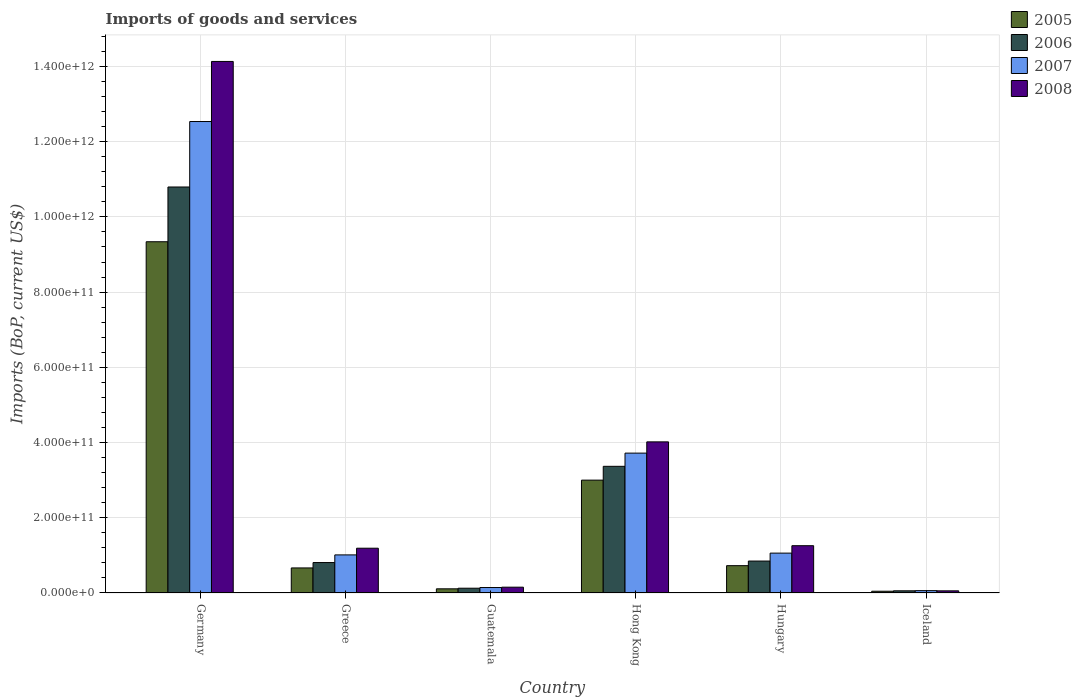How many different coloured bars are there?
Offer a terse response. 4. How many groups of bars are there?
Provide a succinct answer. 6. Are the number of bars per tick equal to the number of legend labels?
Offer a terse response. Yes. Are the number of bars on each tick of the X-axis equal?
Offer a very short reply. Yes. In how many cases, is the number of bars for a given country not equal to the number of legend labels?
Provide a succinct answer. 0. What is the amount spent on imports in 2008 in Germany?
Ensure brevity in your answer.  1.41e+12. Across all countries, what is the maximum amount spent on imports in 2007?
Offer a very short reply. 1.25e+12. Across all countries, what is the minimum amount spent on imports in 2008?
Your response must be concise. 5.71e+09. In which country was the amount spent on imports in 2006 maximum?
Your response must be concise. Germany. In which country was the amount spent on imports in 2007 minimum?
Offer a very short reply. Iceland. What is the total amount spent on imports in 2005 in the graph?
Make the answer very short. 1.39e+12. What is the difference between the amount spent on imports in 2006 in Guatemala and that in Hong Kong?
Offer a very short reply. -3.24e+11. What is the difference between the amount spent on imports in 2006 in Guatemala and the amount spent on imports in 2007 in Germany?
Ensure brevity in your answer.  -1.24e+12. What is the average amount spent on imports in 2007 per country?
Provide a succinct answer. 3.09e+11. What is the difference between the amount spent on imports of/in 2008 and amount spent on imports of/in 2006 in Iceland?
Keep it short and to the point. -1.07e+08. In how many countries, is the amount spent on imports in 2007 greater than 600000000000 US$?
Your answer should be compact. 1. What is the ratio of the amount spent on imports in 2008 in Germany to that in Iceland?
Offer a terse response. 247.52. Is the difference between the amount spent on imports in 2008 in Greece and Hungary greater than the difference between the amount spent on imports in 2006 in Greece and Hungary?
Provide a succinct answer. No. What is the difference between the highest and the second highest amount spent on imports in 2005?
Give a very brief answer. 6.34e+11. What is the difference between the highest and the lowest amount spent on imports in 2007?
Offer a terse response. 1.25e+12. In how many countries, is the amount spent on imports in 2007 greater than the average amount spent on imports in 2007 taken over all countries?
Provide a short and direct response. 2. Is the sum of the amount spent on imports in 2006 in Greece and Iceland greater than the maximum amount spent on imports in 2007 across all countries?
Your answer should be very brief. No. Is it the case that in every country, the sum of the amount spent on imports in 2008 and amount spent on imports in 2007 is greater than the sum of amount spent on imports in 2006 and amount spent on imports in 2005?
Offer a terse response. No. What does the 4th bar from the left in Iceland represents?
Your response must be concise. 2008. Is it the case that in every country, the sum of the amount spent on imports in 2007 and amount spent on imports in 2008 is greater than the amount spent on imports in 2005?
Your answer should be compact. Yes. How many bars are there?
Offer a terse response. 24. Are all the bars in the graph horizontal?
Your response must be concise. No. How many countries are there in the graph?
Make the answer very short. 6. What is the difference between two consecutive major ticks on the Y-axis?
Your answer should be very brief. 2.00e+11. Does the graph contain any zero values?
Provide a succinct answer. No. Does the graph contain grids?
Your response must be concise. Yes. How many legend labels are there?
Ensure brevity in your answer.  4. How are the legend labels stacked?
Provide a succinct answer. Vertical. What is the title of the graph?
Give a very brief answer. Imports of goods and services. What is the label or title of the X-axis?
Your answer should be very brief. Country. What is the label or title of the Y-axis?
Your response must be concise. Imports (BoP, current US$). What is the Imports (BoP, current US$) of 2005 in Germany?
Your answer should be compact. 9.34e+11. What is the Imports (BoP, current US$) in 2006 in Germany?
Keep it short and to the point. 1.08e+12. What is the Imports (BoP, current US$) in 2007 in Germany?
Offer a terse response. 1.25e+12. What is the Imports (BoP, current US$) of 2008 in Germany?
Offer a terse response. 1.41e+12. What is the Imports (BoP, current US$) of 2005 in Greece?
Ensure brevity in your answer.  6.66e+1. What is the Imports (BoP, current US$) of 2006 in Greece?
Ensure brevity in your answer.  8.09e+1. What is the Imports (BoP, current US$) in 2007 in Greece?
Your answer should be very brief. 1.01e+11. What is the Imports (BoP, current US$) in 2008 in Greece?
Make the answer very short. 1.19e+11. What is the Imports (BoP, current US$) of 2005 in Guatemala?
Your response must be concise. 1.11e+1. What is the Imports (BoP, current US$) of 2006 in Guatemala?
Your answer should be very brief. 1.27e+1. What is the Imports (BoP, current US$) in 2007 in Guatemala?
Make the answer very short. 1.45e+1. What is the Imports (BoP, current US$) in 2008 in Guatemala?
Offer a terse response. 1.55e+1. What is the Imports (BoP, current US$) in 2005 in Hong Kong?
Your answer should be compact. 3.00e+11. What is the Imports (BoP, current US$) in 2006 in Hong Kong?
Your answer should be very brief. 3.37e+11. What is the Imports (BoP, current US$) in 2007 in Hong Kong?
Your response must be concise. 3.72e+11. What is the Imports (BoP, current US$) in 2008 in Hong Kong?
Ensure brevity in your answer.  4.02e+11. What is the Imports (BoP, current US$) in 2005 in Hungary?
Provide a succinct answer. 7.26e+1. What is the Imports (BoP, current US$) of 2006 in Hungary?
Keep it short and to the point. 8.49e+1. What is the Imports (BoP, current US$) of 2007 in Hungary?
Ensure brevity in your answer.  1.06e+11. What is the Imports (BoP, current US$) in 2008 in Hungary?
Provide a short and direct response. 1.26e+11. What is the Imports (BoP, current US$) in 2005 in Iceland?
Offer a terse response. 4.68e+09. What is the Imports (BoP, current US$) of 2006 in Iceland?
Provide a succinct answer. 5.82e+09. What is the Imports (BoP, current US$) in 2007 in Iceland?
Offer a very short reply. 6.27e+09. What is the Imports (BoP, current US$) in 2008 in Iceland?
Ensure brevity in your answer.  5.71e+09. Across all countries, what is the maximum Imports (BoP, current US$) in 2005?
Your answer should be very brief. 9.34e+11. Across all countries, what is the maximum Imports (BoP, current US$) of 2006?
Make the answer very short. 1.08e+12. Across all countries, what is the maximum Imports (BoP, current US$) in 2007?
Your answer should be very brief. 1.25e+12. Across all countries, what is the maximum Imports (BoP, current US$) of 2008?
Your answer should be compact. 1.41e+12. Across all countries, what is the minimum Imports (BoP, current US$) in 2005?
Keep it short and to the point. 4.68e+09. Across all countries, what is the minimum Imports (BoP, current US$) in 2006?
Offer a terse response. 5.82e+09. Across all countries, what is the minimum Imports (BoP, current US$) of 2007?
Keep it short and to the point. 6.27e+09. Across all countries, what is the minimum Imports (BoP, current US$) in 2008?
Offer a very short reply. 5.71e+09. What is the total Imports (BoP, current US$) of 2005 in the graph?
Your response must be concise. 1.39e+12. What is the total Imports (BoP, current US$) of 2006 in the graph?
Offer a very short reply. 1.60e+12. What is the total Imports (BoP, current US$) in 2007 in the graph?
Keep it short and to the point. 1.85e+12. What is the total Imports (BoP, current US$) of 2008 in the graph?
Your answer should be compact. 2.08e+12. What is the difference between the Imports (BoP, current US$) in 2005 in Germany and that in Greece?
Offer a very short reply. 8.67e+11. What is the difference between the Imports (BoP, current US$) in 2006 in Germany and that in Greece?
Give a very brief answer. 9.98e+11. What is the difference between the Imports (BoP, current US$) in 2007 in Germany and that in Greece?
Give a very brief answer. 1.15e+12. What is the difference between the Imports (BoP, current US$) of 2008 in Germany and that in Greece?
Make the answer very short. 1.29e+12. What is the difference between the Imports (BoP, current US$) in 2005 in Germany and that in Guatemala?
Ensure brevity in your answer.  9.23e+11. What is the difference between the Imports (BoP, current US$) of 2006 in Germany and that in Guatemala?
Provide a succinct answer. 1.07e+12. What is the difference between the Imports (BoP, current US$) of 2007 in Germany and that in Guatemala?
Your response must be concise. 1.24e+12. What is the difference between the Imports (BoP, current US$) in 2008 in Germany and that in Guatemala?
Offer a terse response. 1.40e+12. What is the difference between the Imports (BoP, current US$) of 2005 in Germany and that in Hong Kong?
Provide a succinct answer. 6.34e+11. What is the difference between the Imports (BoP, current US$) in 2006 in Germany and that in Hong Kong?
Give a very brief answer. 7.43e+11. What is the difference between the Imports (BoP, current US$) in 2007 in Germany and that in Hong Kong?
Keep it short and to the point. 8.82e+11. What is the difference between the Imports (BoP, current US$) in 2008 in Germany and that in Hong Kong?
Your answer should be compact. 1.01e+12. What is the difference between the Imports (BoP, current US$) of 2005 in Germany and that in Hungary?
Your response must be concise. 8.61e+11. What is the difference between the Imports (BoP, current US$) of 2006 in Germany and that in Hungary?
Offer a very short reply. 9.95e+11. What is the difference between the Imports (BoP, current US$) in 2007 in Germany and that in Hungary?
Provide a short and direct response. 1.15e+12. What is the difference between the Imports (BoP, current US$) in 2008 in Germany and that in Hungary?
Provide a succinct answer. 1.29e+12. What is the difference between the Imports (BoP, current US$) of 2005 in Germany and that in Iceland?
Your response must be concise. 9.29e+11. What is the difference between the Imports (BoP, current US$) of 2006 in Germany and that in Iceland?
Make the answer very short. 1.07e+12. What is the difference between the Imports (BoP, current US$) in 2007 in Germany and that in Iceland?
Offer a terse response. 1.25e+12. What is the difference between the Imports (BoP, current US$) in 2008 in Germany and that in Iceland?
Make the answer very short. 1.41e+12. What is the difference between the Imports (BoP, current US$) in 2005 in Greece and that in Guatemala?
Ensure brevity in your answer.  5.55e+1. What is the difference between the Imports (BoP, current US$) of 2006 in Greece and that in Guatemala?
Make the answer very short. 6.82e+1. What is the difference between the Imports (BoP, current US$) in 2007 in Greece and that in Guatemala?
Ensure brevity in your answer.  8.68e+1. What is the difference between the Imports (BoP, current US$) in 2008 in Greece and that in Guatemala?
Keep it short and to the point. 1.04e+11. What is the difference between the Imports (BoP, current US$) of 2005 in Greece and that in Hong Kong?
Keep it short and to the point. -2.33e+11. What is the difference between the Imports (BoP, current US$) of 2006 in Greece and that in Hong Kong?
Offer a very short reply. -2.56e+11. What is the difference between the Imports (BoP, current US$) of 2007 in Greece and that in Hong Kong?
Ensure brevity in your answer.  -2.71e+11. What is the difference between the Imports (BoP, current US$) in 2008 in Greece and that in Hong Kong?
Your answer should be very brief. -2.83e+11. What is the difference between the Imports (BoP, current US$) of 2005 in Greece and that in Hungary?
Ensure brevity in your answer.  -6.02e+09. What is the difference between the Imports (BoP, current US$) in 2006 in Greece and that in Hungary?
Your answer should be compact. -3.99e+09. What is the difference between the Imports (BoP, current US$) of 2007 in Greece and that in Hungary?
Ensure brevity in your answer.  -4.71e+09. What is the difference between the Imports (BoP, current US$) of 2008 in Greece and that in Hungary?
Ensure brevity in your answer.  -6.66e+09. What is the difference between the Imports (BoP, current US$) in 2005 in Greece and that in Iceland?
Give a very brief answer. 6.19e+1. What is the difference between the Imports (BoP, current US$) of 2006 in Greece and that in Iceland?
Offer a very short reply. 7.51e+1. What is the difference between the Imports (BoP, current US$) in 2007 in Greece and that in Iceland?
Give a very brief answer. 9.50e+1. What is the difference between the Imports (BoP, current US$) of 2008 in Greece and that in Iceland?
Provide a short and direct response. 1.13e+11. What is the difference between the Imports (BoP, current US$) of 2005 in Guatemala and that in Hong Kong?
Your answer should be very brief. -2.89e+11. What is the difference between the Imports (BoP, current US$) of 2006 in Guatemala and that in Hong Kong?
Your answer should be very brief. -3.24e+11. What is the difference between the Imports (BoP, current US$) in 2007 in Guatemala and that in Hong Kong?
Your response must be concise. -3.57e+11. What is the difference between the Imports (BoP, current US$) in 2008 in Guatemala and that in Hong Kong?
Make the answer very short. -3.86e+11. What is the difference between the Imports (BoP, current US$) of 2005 in Guatemala and that in Hungary?
Offer a terse response. -6.15e+1. What is the difference between the Imports (BoP, current US$) in 2006 in Guatemala and that in Hungary?
Offer a terse response. -7.22e+1. What is the difference between the Imports (BoP, current US$) in 2007 in Guatemala and that in Hungary?
Provide a succinct answer. -9.15e+1. What is the difference between the Imports (BoP, current US$) in 2008 in Guatemala and that in Hungary?
Your response must be concise. -1.10e+11. What is the difference between the Imports (BoP, current US$) in 2005 in Guatemala and that in Iceland?
Your answer should be very brief. 6.42e+09. What is the difference between the Imports (BoP, current US$) in 2006 in Guatemala and that in Iceland?
Your answer should be compact. 6.90e+09. What is the difference between the Imports (BoP, current US$) in 2007 in Guatemala and that in Iceland?
Ensure brevity in your answer.  8.24e+09. What is the difference between the Imports (BoP, current US$) in 2008 in Guatemala and that in Iceland?
Provide a succinct answer. 9.75e+09. What is the difference between the Imports (BoP, current US$) of 2005 in Hong Kong and that in Hungary?
Offer a terse response. 2.27e+11. What is the difference between the Imports (BoP, current US$) of 2006 in Hong Kong and that in Hungary?
Ensure brevity in your answer.  2.52e+11. What is the difference between the Imports (BoP, current US$) of 2007 in Hong Kong and that in Hungary?
Make the answer very short. 2.66e+11. What is the difference between the Imports (BoP, current US$) of 2008 in Hong Kong and that in Hungary?
Ensure brevity in your answer.  2.76e+11. What is the difference between the Imports (BoP, current US$) of 2005 in Hong Kong and that in Iceland?
Your answer should be very brief. 2.95e+11. What is the difference between the Imports (BoP, current US$) of 2006 in Hong Kong and that in Iceland?
Offer a terse response. 3.31e+11. What is the difference between the Imports (BoP, current US$) in 2007 in Hong Kong and that in Iceland?
Provide a succinct answer. 3.66e+11. What is the difference between the Imports (BoP, current US$) of 2008 in Hong Kong and that in Iceland?
Your answer should be very brief. 3.96e+11. What is the difference between the Imports (BoP, current US$) of 2005 in Hungary and that in Iceland?
Offer a very short reply. 6.80e+1. What is the difference between the Imports (BoP, current US$) of 2006 in Hungary and that in Iceland?
Offer a terse response. 7.91e+1. What is the difference between the Imports (BoP, current US$) of 2007 in Hungary and that in Iceland?
Provide a succinct answer. 9.97e+1. What is the difference between the Imports (BoP, current US$) in 2008 in Hungary and that in Iceland?
Provide a short and direct response. 1.20e+11. What is the difference between the Imports (BoP, current US$) in 2005 in Germany and the Imports (BoP, current US$) in 2006 in Greece?
Give a very brief answer. 8.53e+11. What is the difference between the Imports (BoP, current US$) of 2005 in Germany and the Imports (BoP, current US$) of 2007 in Greece?
Your answer should be very brief. 8.33e+11. What is the difference between the Imports (BoP, current US$) in 2005 in Germany and the Imports (BoP, current US$) in 2008 in Greece?
Provide a short and direct response. 8.15e+11. What is the difference between the Imports (BoP, current US$) of 2006 in Germany and the Imports (BoP, current US$) of 2007 in Greece?
Your response must be concise. 9.78e+11. What is the difference between the Imports (BoP, current US$) in 2006 in Germany and the Imports (BoP, current US$) in 2008 in Greece?
Provide a succinct answer. 9.60e+11. What is the difference between the Imports (BoP, current US$) in 2007 in Germany and the Imports (BoP, current US$) in 2008 in Greece?
Ensure brevity in your answer.  1.13e+12. What is the difference between the Imports (BoP, current US$) of 2005 in Germany and the Imports (BoP, current US$) of 2006 in Guatemala?
Keep it short and to the point. 9.21e+11. What is the difference between the Imports (BoP, current US$) of 2005 in Germany and the Imports (BoP, current US$) of 2007 in Guatemala?
Provide a succinct answer. 9.19e+11. What is the difference between the Imports (BoP, current US$) of 2005 in Germany and the Imports (BoP, current US$) of 2008 in Guatemala?
Offer a terse response. 9.18e+11. What is the difference between the Imports (BoP, current US$) in 2006 in Germany and the Imports (BoP, current US$) in 2007 in Guatemala?
Keep it short and to the point. 1.06e+12. What is the difference between the Imports (BoP, current US$) of 2006 in Germany and the Imports (BoP, current US$) of 2008 in Guatemala?
Give a very brief answer. 1.06e+12. What is the difference between the Imports (BoP, current US$) of 2007 in Germany and the Imports (BoP, current US$) of 2008 in Guatemala?
Your answer should be compact. 1.24e+12. What is the difference between the Imports (BoP, current US$) in 2005 in Germany and the Imports (BoP, current US$) in 2006 in Hong Kong?
Give a very brief answer. 5.97e+11. What is the difference between the Imports (BoP, current US$) of 2005 in Germany and the Imports (BoP, current US$) of 2007 in Hong Kong?
Give a very brief answer. 5.62e+11. What is the difference between the Imports (BoP, current US$) of 2005 in Germany and the Imports (BoP, current US$) of 2008 in Hong Kong?
Offer a very short reply. 5.32e+11. What is the difference between the Imports (BoP, current US$) of 2006 in Germany and the Imports (BoP, current US$) of 2007 in Hong Kong?
Your response must be concise. 7.08e+11. What is the difference between the Imports (BoP, current US$) in 2006 in Germany and the Imports (BoP, current US$) in 2008 in Hong Kong?
Give a very brief answer. 6.78e+11. What is the difference between the Imports (BoP, current US$) of 2007 in Germany and the Imports (BoP, current US$) of 2008 in Hong Kong?
Your answer should be compact. 8.52e+11. What is the difference between the Imports (BoP, current US$) in 2005 in Germany and the Imports (BoP, current US$) in 2006 in Hungary?
Provide a succinct answer. 8.49e+11. What is the difference between the Imports (BoP, current US$) of 2005 in Germany and the Imports (BoP, current US$) of 2007 in Hungary?
Provide a short and direct response. 8.28e+11. What is the difference between the Imports (BoP, current US$) in 2005 in Germany and the Imports (BoP, current US$) in 2008 in Hungary?
Make the answer very short. 8.08e+11. What is the difference between the Imports (BoP, current US$) in 2006 in Germany and the Imports (BoP, current US$) in 2007 in Hungary?
Provide a short and direct response. 9.73e+11. What is the difference between the Imports (BoP, current US$) in 2006 in Germany and the Imports (BoP, current US$) in 2008 in Hungary?
Your answer should be compact. 9.54e+11. What is the difference between the Imports (BoP, current US$) of 2007 in Germany and the Imports (BoP, current US$) of 2008 in Hungary?
Make the answer very short. 1.13e+12. What is the difference between the Imports (BoP, current US$) of 2005 in Germany and the Imports (BoP, current US$) of 2006 in Iceland?
Your answer should be very brief. 9.28e+11. What is the difference between the Imports (BoP, current US$) in 2005 in Germany and the Imports (BoP, current US$) in 2007 in Iceland?
Your answer should be very brief. 9.28e+11. What is the difference between the Imports (BoP, current US$) of 2005 in Germany and the Imports (BoP, current US$) of 2008 in Iceland?
Your answer should be compact. 9.28e+11. What is the difference between the Imports (BoP, current US$) of 2006 in Germany and the Imports (BoP, current US$) of 2007 in Iceland?
Your response must be concise. 1.07e+12. What is the difference between the Imports (BoP, current US$) of 2006 in Germany and the Imports (BoP, current US$) of 2008 in Iceland?
Keep it short and to the point. 1.07e+12. What is the difference between the Imports (BoP, current US$) in 2007 in Germany and the Imports (BoP, current US$) in 2008 in Iceland?
Your answer should be compact. 1.25e+12. What is the difference between the Imports (BoP, current US$) of 2005 in Greece and the Imports (BoP, current US$) of 2006 in Guatemala?
Keep it short and to the point. 5.39e+1. What is the difference between the Imports (BoP, current US$) in 2005 in Greece and the Imports (BoP, current US$) in 2007 in Guatemala?
Your answer should be very brief. 5.21e+1. What is the difference between the Imports (BoP, current US$) in 2005 in Greece and the Imports (BoP, current US$) in 2008 in Guatemala?
Offer a very short reply. 5.12e+1. What is the difference between the Imports (BoP, current US$) of 2006 in Greece and the Imports (BoP, current US$) of 2007 in Guatemala?
Provide a succinct answer. 6.64e+1. What is the difference between the Imports (BoP, current US$) in 2006 in Greece and the Imports (BoP, current US$) in 2008 in Guatemala?
Give a very brief answer. 6.55e+1. What is the difference between the Imports (BoP, current US$) of 2007 in Greece and the Imports (BoP, current US$) of 2008 in Guatemala?
Provide a short and direct response. 8.58e+1. What is the difference between the Imports (BoP, current US$) in 2005 in Greece and the Imports (BoP, current US$) in 2006 in Hong Kong?
Your response must be concise. -2.70e+11. What is the difference between the Imports (BoP, current US$) of 2005 in Greece and the Imports (BoP, current US$) of 2007 in Hong Kong?
Your response must be concise. -3.05e+11. What is the difference between the Imports (BoP, current US$) of 2005 in Greece and the Imports (BoP, current US$) of 2008 in Hong Kong?
Provide a short and direct response. -3.35e+11. What is the difference between the Imports (BoP, current US$) of 2006 in Greece and the Imports (BoP, current US$) of 2007 in Hong Kong?
Make the answer very short. -2.91e+11. What is the difference between the Imports (BoP, current US$) of 2006 in Greece and the Imports (BoP, current US$) of 2008 in Hong Kong?
Keep it short and to the point. -3.21e+11. What is the difference between the Imports (BoP, current US$) in 2007 in Greece and the Imports (BoP, current US$) in 2008 in Hong Kong?
Offer a very short reply. -3.01e+11. What is the difference between the Imports (BoP, current US$) in 2005 in Greece and the Imports (BoP, current US$) in 2006 in Hungary?
Your response must be concise. -1.83e+1. What is the difference between the Imports (BoP, current US$) in 2005 in Greece and the Imports (BoP, current US$) in 2007 in Hungary?
Provide a short and direct response. -3.94e+1. What is the difference between the Imports (BoP, current US$) of 2005 in Greece and the Imports (BoP, current US$) of 2008 in Hungary?
Offer a terse response. -5.91e+1. What is the difference between the Imports (BoP, current US$) in 2006 in Greece and the Imports (BoP, current US$) in 2007 in Hungary?
Keep it short and to the point. -2.51e+1. What is the difference between the Imports (BoP, current US$) in 2006 in Greece and the Imports (BoP, current US$) in 2008 in Hungary?
Provide a succinct answer. -4.48e+1. What is the difference between the Imports (BoP, current US$) of 2007 in Greece and the Imports (BoP, current US$) of 2008 in Hungary?
Ensure brevity in your answer.  -2.44e+1. What is the difference between the Imports (BoP, current US$) of 2005 in Greece and the Imports (BoP, current US$) of 2006 in Iceland?
Offer a terse response. 6.08e+1. What is the difference between the Imports (BoP, current US$) in 2005 in Greece and the Imports (BoP, current US$) in 2007 in Iceland?
Make the answer very short. 6.03e+1. What is the difference between the Imports (BoP, current US$) of 2005 in Greece and the Imports (BoP, current US$) of 2008 in Iceland?
Provide a succinct answer. 6.09e+1. What is the difference between the Imports (BoP, current US$) in 2006 in Greece and the Imports (BoP, current US$) in 2007 in Iceland?
Your answer should be compact. 7.47e+1. What is the difference between the Imports (BoP, current US$) in 2006 in Greece and the Imports (BoP, current US$) in 2008 in Iceland?
Make the answer very short. 7.52e+1. What is the difference between the Imports (BoP, current US$) of 2007 in Greece and the Imports (BoP, current US$) of 2008 in Iceland?
Give a very brief answer. 9.56e+1. What is the difference between the Imports (BoP, current US$) of 2005 in Guatemala and the Imports (BoP, current US$) of 2006 in Hong Kong?
Your answer should be very brief. -3.26e+11. What is the difference between the Imports (BoP, current US$) of 2005 in Guatemala and the Imports (BoP, current US$) of 2007 in Hong Kong?
Give a very brief answer. -3.61e+11. What is the difference between the Imports (BoP, current US$) in 2005 in Guatemala and the Imports (BoP, current US$) in 2008 in Hong Kong?
Provide a short and direct response. -3.91e+11. What is the difference between the Imports (BoP, current US$) of 2006 in Guatemala and the Imports (BoP, current US$) of 2007 in Hong Kong?
Give a very brief answer. -3.59e+11. What is the difference between the Imports (BoP, current US$) in 2006 in Guatemala and the Imports (BoP, current US$) in 2008 in Hong Kong?
Give a very brief answer. -3.89e+11. What is the difference between the Imports (BoP, current US$) of 2007 in Guatemala and the Imports (BoP, current US$) of 2008 in Hong Kong?
Keep it short and to the point. -3.87e+11. What is the difference between the Imports (BoP, current US$) of 2005 in Guatemala and the Imports (BoP, current US$) of 2006 in Hungary?
Give a very brief answer. -7.38e+1. What is the difference between the Imports (BoP, current US$) in 2005 in Guatemala and the Imports (BoP, current US$) in 2007 in Hungary?
Give a very brief answer. -9.49e+1. What is the difference between the Imports (BoP, current US$) in 2005 in Guatemala and the Imports (BoP, current US$) in 2008 in Hungary?
Your answer should be very brief. -1.15e+11. What is the difference between the Imports (BoP, current US$) of 2006 in Guatemala and the Imports (BoP, current US$) of 2007 in Hungary?
Provide a succinct answer. -9.33e+1. What is the difference between the Imports (BoP, current US$) in 2006 in Guatemala and the Imports (BoP, current US$) in 2008 in Hungary?
Offer a very short reply. -1.13e+11. What is the difference between the Imports (BoP, current US$) of 2007 in Guatemala and the Imports (BoP, current US$) of 2008 in Hungary?
Keep it short and to the point. -1.11e+11. What is the difference between the Imports (BoP, current US$) of 2005 in Guatemala and the Imports (BoP, current US$) of 2006 in Iceland?
Ensure brevity in your answer.  5.28e+09. What is the difference between the Imports (BoP, current US$) in 2005 in Guatemala and the Imports (BoP, current US$) in 2007 in Iceland?
Make the answer very short. 4.83e+09. What is the difference between the Imports (BoP, current US$) in 2005 in Guatemala and the Imports (BoP, current US$) in 2008 in Iceland?
Keep it short and to the point. 5.39e+09. What is the difference between the Imports (BoP, current US$) in 2006 in Guatemala and the Imports (BoP, current US$) in 2007 in Iceland?
Make the answer very short. 6.44e+09. What is the difference between the Imports (BoP, current US$) of 2006 in Guatemala and the Imports (BoP, current US$) of 2008 in Iceland?
Provide a short and direct response. 7.00e+09. What is the difference between the Imports (BoP, current US$) in 2007 in Guatemala and the Imports (BoP, current US$) in 2008 in Iceland?
Your answer should be compact. 8.80e+09. What is the difference between the Imports (BoP, current US$) in 2005 in Hong Kong and the Imports (BoP, current US$) in 2006 in Hungary?
Offer a very short reply. 2.15e+11. What is the difference between the Imports (BoP, current US$) of 2005 in Hong Kong and the Imports (BoP, current US$) of 2007 in Hungary?
Give a very brief answer. 1.94e+11. What is the difference between the Imports (BoP, current US$) in 2005 in Hong Kong and the Imports (BoP, current US$) in 2008 in Hungary?
Your answer should be compact. 1.74e+11. What is the difference between the Imports (BoP, current US$) of 2006 in Hong Kong and the Imports (BoP, current US$) of 2007 in Hungary?
Make the answer very short. 2.31e+11. What is the difference between the Imports (BoP, current US$) in 2006 in Hong Kong and the Imports (BoP, current US$) in 2008 in Hungary?
Your answer should be very brief. 2.11e+11. What is the difference between the Imports (BoP, current US$) of 2007 in Hong Kong and the Imports (BoP, current US$) of 2008 in Hungary?
Your response must be concise. 2.46e+11. What is the difference between the Imports (BoP, current US$) of 2005 in Hong Kong and the Imports (BoP, current US$) of 2006 in Iceland?
Provide a succinct answer. 2.94e+11. What is the difference between the Imports (BoP, current US$) in 2005 in Hong Kong and the Imports (BoP, current US$) in 2007 in Iceland?
Your response must be concise. 2.94e+11. What is the difference between the Imports (BoP, current US$) of 2005 in Hong Kong and the Imports (BoP, current US$) of 2008 in Iceland?
Make the answer very short. 2.94e+11. What is the difference between the Imports (BoP, current US$) of 2006 in Hong Kong and the Imports (BoP, current US$) of 2007 in Iceland?
Offer a very short reply. 3.30e+11. What is the difference between the Imports (BoP, current US$) in 2006 in Hong Kong and the Imports (BoP, current US$) in 2008 in Iceland?
Your answer should be compact. 3.31e+11. What is the difference between the Imports (BoP, current US$) of 2007 in Hong Kong and the Imports (BoP, current US$) of 2008 in Iceland?
Provide a short and direct response. 3.66e+11. What is the difference between the Imports (BoP, current US$) in 2005 in Hungary and the Imports (BoP, current US$) in 2006 in Iceland?
Make the answer very short. 6.68e+1. What is the difference between the Imports (BoP, current US$) in 2005 in Hungary and the Imports (BoP, current US$) in 2007 in Iceland?
Provide a short and direct response. 6.64e+1. What is the difference between the Imports (BoP, current US$) in 2005 in Hungary and the Imports (BoP, current US$) in 2008 in Iceland?
Your response must be concise. 6.69e+1. What is the difference between the Imports (BoP, current US$) of 2006 in Hungary and the Imports (BoP, current US$) of 2007 in Iceland?
Your response must be concise. 7.86e+1. What is the difference between the Imports (BoP, current US$) in 2006 in Hungary and the Imports (BoP, current US$) in 2008 in Iceland?
Provide a succinct answer. 7.92e+1. What is the difference between the Imports (BoP, current US$) of 2007 in Hungary and the Imports (BoP, current US$) of 2008 in Iceland?
Your answer should be compact. 1.00e+11. What is the average Imports (BoP, current US$) in 2005 per country?
Offer a terse response. 2.31e+11. What is the average Imports (BoP, current US$) of 2006 per country?
Make the answer very short. 2.67e+11. What is the average Imports (BoP, current US$) of 2007 per country?
Keep it short and to the point. 3.09e+11. What is the average Imports (BoP, current US$) in 2008 per country?
Make the answer very short. 3.47e+11. What is the difference between the Imports (BoP, current US$) in 2005 and Imports (BoP, current US$) in 2006 in Germany?
Your answer should be compact. -1.46e+11. What is the difference between the Imports (BoP, current US$) of 2005 and Imports (BoP, current US$) of 2007 in Germany?
Keep it short and to the point. -3.20e+11. What is the difference between the Imports (BoP, current US$) of 2005 and Imports (BoP, current US$) of 2008 in Germany?
Offer a very short reply. -4.79e+11. What is the difference between the Imports (BoP, current US$) of 2006 and Imports (BoP, current US$) of 2007 in Germany?
Provide a succinct answer. -1.74e+11. What is the difference between the Imports (BoP, current US$) of 2006 and Imports (BoP, current US$) of 2008 in Germany?
Provide a succinct answer. -3.34e+11. What is the difference between the Imports (BoP, current US$) in 2007 and Imports (BoP, current US$) in 2008 in Germany?
Ensure brevity in your answer.  -1.60e+11. What is the difference between the Imports (BoP, current US$) of 2005 and Imports (BoP, current US$) of 2006 in Greece?
Offer a terse response. -1.43e+1. What is the difference between the Imports (BoP, current US$) of 2005 and Imports (BoP, current US$) of 2007 in Greece?
Provide a succinct answer. -3.47e+1. What is the difference between the Imports (BoP, current US$) in 2005 and Imports (BoP, current US$) in 2008 in Greece?
Your answer should be compact. -5.25e+1. What is the difference between the Imports (BoP, current US$) in 2006 and Imports (BoP, current US$) in 2007 in Greece?
Make the answer very short. -2.04e+1. What is the difference between the Imports (BoP, current US$) of 2006 and Imports (BoP, current US$) of 2008 in Greece?
Your response must be concise. -3.81e+1. What is the difference between the Imports (BoP, current US$) in 2007 and Imports (BoP, current US$) in 2008 in Greece?
Your response must be concise. -1.78e+1. What is the difference between the Imports (BoP, current US$) of 2005 and Imports (BoP, current US$) of 2006 in Guatemala?
Offer a very short reply. -1.61e+09. What is the difference between the Imports (BoP, current US$) of 2005 and Imports (BoP, current US$) of 2007 in Guatemala?
Offer a terse response. -3.41e+09. What is the difference between the Imports (BoP, current US$) of 2005 and Imports (BoP, current US$) of 2008 in Guatemala?
Keep it short and to the point. -4.36e+09. What is the difference between the Imports (BoP, current US$) in 2006 and Imports (BoP, current US$) in 2007 in Guatemala?
Your answer should be compact. -1.80e+09. What is the difference between the Imports (BoP, current US$) of 2006 and Imports (BoP, current US$) of 2008 in Guatemala?
Your answer should be very brief. -2.75e+09. What is the difference between the Imports (BoP, current US$) of 2007 and Imports (BoP, current US$) of 2008 in Guatemala?
Your answer should be very brief. -9.53e+08. What is the difference between the Imports (BoP, current US$) in 2005 and Imports (BoP, current US$) in 2006 in Hong Kong?
Offer a terse response. -3.67e+1. What is the difference between the Imports (BoP, current US$) in 2005 and Imports (BoP, current US$) in 2007 in Hong Kong?
Provide a short and direct response. -7.18e+1. What is the difference between the Imports (BoP, current US$) in 2005 and Imports (BoP, current US$) in 2008 in Hong Kong?
Provide a short and direct response. -1.02e+11. What is the difference between the Imports (BoP, current US$) in 2006 and Imports (BoP, current US$) in 2007 in Hong Kong?
Provide a short and direct response. -3.51e+1. What is the difference between the Imports (BoP, current US$) in 2006 and Imports (BoP, current US$) in 2008 in Hong Kong?
Offer a very short reply. -6.50e+1. What is the difference between the Imports (BoP, current US$) in 2007 and Imports (BoP, current US$) in 2008 in Hong Kong?
Your answer should be compact. -2.99e+1. What is the difference between the Imports (BoP, current US$) in 2005 and Imports (BoP, current US$) in 2006 in Hungary?
Give a very brief answer. -1.23e+1. What is the difference between the Imports (BoP, current US$) of 2005 and Imports (BoP, current US$) of 2007 in Hungary?
Give a very brief answer. -3.33e+1. What is the difference between the Imports (BoP, current US$) in 2005 and Imports (BoP, current US$) in 2008 in Hungary?
Offer a terse response. -5.31e+1. What is the difference between the Imports (BoP, current US$) in 2006 and Imports (BoP, current US$) in 2007 in Hungary?
Give a very brief answer. -2.11e+1. What is the difference between the Imports (BoP, current US$) in 2006 and Imports (BoP, current US$) in 2008 in Hungary?
Provide a succinct answer. -4.08e+1. What is the difference between the Imports (BoP, current US$) in 2007 and Imports (BoP, current US$) in 2008 in Hungary?
Keep it short and to the point. -1.97e+1. What is the difference between the Imports (BoP, current US$) in 2005 and Imports (BoP, current US$) in 2006 in Iceland?
Ensure brevity in your answer.  -1.13e+09. What is the difference between the Imports (BoP, current US$) of 2005 and Imports (BoP, current US$) of 2007 in Iceland?
Ensure brevity in your answer.  -1.59e+09. What is the difference between the Imports (BoP, current US$) of 2005 and Imports (BoP, current US$) of 2008 in Iceland?
Provide a short and direct response. -1.03e+09. What is the difference between the Imports (BoP, current US$) in 2006 and Imports (BoP, current US$) in 2007 in Iceland?
Provide a succinct answer. -4.53e+08. What is the difference between the Imports (BoP, current US$) of 2006 and Imports (BoP, current US$) of 2008 in Iceland?
Provide a succinct answer. 1.07e+08. What is the difference between the Imports (BoP, current US$) of 2007 and Imports (BoP, current US$) of 2008 in Iceland?
Provide a succinct answer. 5.60e+08. What is the ratio of the Imports (BoP, current US$) in 2005 in Germany to that in Greece?
Give a very brief answer. 14.02. What is the ratio of the Imports (BoP, current US$) of 2006 in Germany to that in Greece?
Offer a very short reply. 13.34. What is the ratio of the Imports (BoP, current US$) of 2007 in Germany to that in Greece?
Give a very brief answer. 12.38. What is the ratio of the Imports (BoP, current US$) of 2008 in Germany to that in Greece?
Make the answer very short. 11.87. What is the ratio of the Imports (BoP, current US$) of 2005 in Germany to that in Guatemala?
Ensure brevity in your answer.  84.13. What is the ratio of the Imports (BoP, current US$) in 2006 in Germany to that in Guatemala?
Keep it short and to the point. 84.91. What is the ratio of the Imports (BoP, current US$) in 2007 in Germany to that in Guatemala?
Offer a very short reply. 86.38. What is the ratio of the Imports (BoP, current US$) in 2008 in Germany to that in Guatemala?
Your answer should be compact. 91.38. What is the ratio of the Imports (BoP, current US$) of 2005 in Germany to that in Hong Kong?
Provide a succinct answer. 3.11. What is the ratio of the Imports (BoP, current US$) in 2006 in Germany to that in Hong Kong?
Give a very brief answer. 3.21. What is the ratio of the Imports (BoP, current US$) of 2007 in Germany to that in Hong Kong?
Your answer should be very brief. 3.37. What is the ratio of the Imports (BoP, current US$) in 2008 in Germany to that in Hong Kong?
Provide a succinct answer. 3.52. What is the ratio of the Imports (BoP, current US$) in 2005 in Germany to that in Hungary?
Your answer should be very brief. 12.86. What is the ratio of the Imports (BoP, current US$) of 2006 in Germany to that in Hungary?
Ensure brevity in your answer.  12.71. What is the ratio of the Imports (BoP, current US$) in 2007 in Germany to that in Hungary?
Offer a terse response. 11.83. What is the ratio of the Imports (BoP, current US$) in 2008 in Germany to that in Hungary?
Offer a very short reply. 11.24. What is the ratio of the Imports (BoP, current US$) in 2005 in Germany to that in Iceland?
Offer a terse response. 199.47. What is the ratio of the Imports (BoP, current US$) in 2006 in Germany to that in Iceland?
Offer a terse response. 185.59. What is the ratio of the Imports (BoP, current US$) in 2007 in Germany to that in Iceland?
Offer a terse response. 199.93. What is the ratio of the Imports (BoP, current US$) of 2008 in Germany to that in Iceland?
Offer a terse response. 247.52. What is the ratio of the Imports (BoP, current US$) of 2005 in Greece to that in Guatemala?
Provide a short and direct response. 6. What is the ratio of the Imports (BoP, current US$) of 2006 in Greece to that in Guatemala?
Offer a very short reply. 6.37. What is the ratio of the Imports (BoP, current US$) in 2007 in Greece to that in Guatemala?
Your answer should be very brief. 6.98. What is the ratio of the Imports (BoP, current US$) in 2008 in Greece to that in Guatemala?
Offer a very short reply. 7.7. What is the ratio of the Imports (BoP, current US$) of 2005 in Greece to that in Hong Kong?
Offer a terse response. 0.22. What is the ratio of the Imports (BoP, current US$) of 2006 in Greece to that in Hong Kong?
Offer a very short reply. 0.24. What is the ratio of the Imports (BoP, current US$) in 2007 in Greece to that in Hong Kong?
Ensure brevity in your answer.  0.27. What is the ratio of the Imports (BoP, current US$) in 2008 in Greece to that in Hong Kong?
Offer a terse response. 0.3. What is the ratio of the Imports (BoP, current US$) in 2005 in Greece to that in Hungary?
Your answer should be very brief. 0.92. What is the ratio of the Imports (BoP, current US$) of 2006 in Greece to that in Hungary?
Provide a short and direct response. 0.95. What is the ratio of the Imports (BoP, current US$) in 2007 in Greece to that in Hungary?
Your answer should be very brief. 0.96. What is the ratio of the Imports (BoP, current US$) in 2008 in Greece to that in Hungary?
Your response must be concise. 0.95. What is the ratio of the Imports (BoP, current US$) of 2005 in Greece to that in Iceland?
Your answer should be very brief. 14.23. What is the ratio of the Imports (BoP, current US$) of 2006 in Greece to that in Iceland?
Offer a terse response. 13.91. What is the ratio of the Imports (BoP, current US$) of 2007 in Greece to that in Iceland?
Keep it short and to the point. 16.15. What is the ratio of the Imports (BoP, current US$) in 2008 in Greece to that in Iceland?
Your answer should be very brief. 20.85. What is the ratio of the Imports (BoP, current US$) of 2005 in Guatemala to that in Hong Kong?
Your response must be concise. 0.04. What is the ratio of the Imports (BoP, current US$) of 2006 in Guatemala to that in Hong Kong?
Your answer should be very brief. 0.04. What is the ratio of the Imports (BoP, current US$) in 2007 in Guatemala to that in Hong Kong?
Make the answer very short. 0.04. What is the ratio of the Imports (BoP, current US$) in 2008 in Guatemala to that in Hong Kong?
Give a very brief answer. 0.04. What is the ratio of the Imports (BoP, current US$) in 2005 in Guatemala to that in Hungary?
Offer a very short reply. 0.15. What is the ratio of the Imports (BoP, current US$) in 2006 in Guatemala to that in Hungary?
Keep it short and to the point. 0.15. What is the ratio of the Imports (BoP, current US$) of 2007 in Guatemala to that in Hungary?
Your response must be concise. 0.14. What is the ratio of the Imports (BoP, current US$) of 2008 in Guatemala to that in Hungary?
Provide a short and direct response. 0.12. What is the ratio of the Imports (BoP, current US$) in 2005 in Guatemala to that in Iceland?
Offer a terse response. 2.37. What is the ratio of the Imports (BoP, current US$) in 2006 in Guatemala to that in Iceland?
Your answer should be very brief. 2.19. What is the ratio of the Imports (BoP, current US$) of 2007 in Guatemala to that in Iceland?
Your response must be concise. 2.31. What is the ratio of the Imports (BoP, current US$) in 2008 in Guatemala to that in Iceland?
Ensure brevity in your answer.  2.71. What is the ratio of the Imports (BoP, current US$) in 2005 in Hong Kong to that in Hungary?
Your response must be concise. 4.13. What is the ratio of the Imports (BoP, current US$) in 2006 in Hong Kong to that in Hungary?
Your answer should be compact. 3.97. What is the ratio of the Imports (BoP, current US$) of 2007 in Hong Kong to that in Hungary?
Keep it short and to the point. 3.51. What is the ratio of the Imports (BoP, current US$) of 2008 in Hong Kong to that in Hungary?
Ensure brevity in your answer.  3.2. What is the ratio of the Imports (BoP, current US$) in 2005 in Hong Kong to that in Iceland?
Your response must be concise. 64.09. What is the ratio of the Imports (BoP, current US$) in 2006 in Hong Kong to that in Iceland?
Your response must be concise. 57.9. What is the ratio of the Imports (BoP, current US$) in 2007 in Hong Kong to that in Iceland?
Ensure brevity in your answer.  59.32. What is the ratio of the Imports (BoP, current US$) of 2008 in Hong Kong to that in Iceland?
Ensure brevity in your answer.  70.37. What is the ratio of the Imports (BoP, current US$) in 2005 in Hungary to that in Iceland?
Offer a very short reply. 15.52. What is the ratio of the Imports (BoP, current US$) of 2006 in Hungary to that in Iceland?
Your response must be concise. 14.6. What is the ratio of the Imports (BoP, current US$) of 2007 in Hungary to that in Iceland?
Offer a very short reply. 16.91. What is the ratio of the Imports (BoP, current US$) of 2008 in Hungary to that in Iceland?
Your answer should be compact. 22.02. What is the difference between the highest and the second highest Imports (BoP, current US$) in 2005?
Make the answer very short. 6.34e+11. What is the difference between the highest and the second highest Imports (BoP, current US$) of 2006?
Your answer should be compact. 7.43e+11. What is the difference between the highest and the second highest Imports (BoP, current US$) of 2007?
Your answer should be very brief. 8.82e+11. What is the difference between the highest and the second highest Imports (BoP, current US$) of 2008?
Provide a short and direct response. 1.01e+12. What is the difference between the highest and the lowest Imports (BoP, current US$) in 2005?
Provide a short and direct response. 9.29e+11. What is the difference between the highest and the lowest Imports (BoP, current US$) in 2006?
Your answer should be compact. 1.07e+12. What is the difference between the highest and the lowest Imports (BoP, current US$) in 2007?
Your answer should be compact. 1.25e+12. What is the difference between the highest and the lowest Imports (BoP, current US$) of 2008?
Your response must be concise. 1.41e+12. 